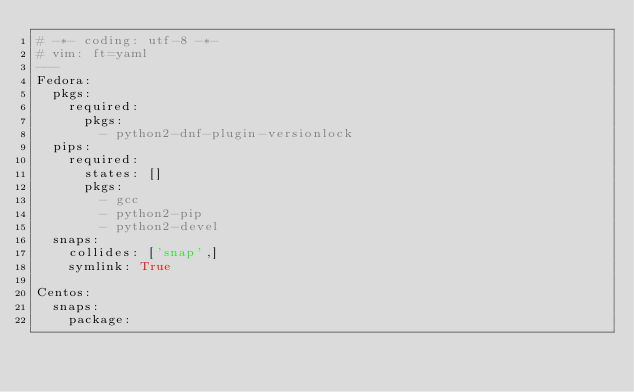Convert code to text. <code><loc_0><loc_0><loc_500><loc_500><_YAML_># -*- coding: utf-8 -*-
# vim: ft=yaml
---
Fedora:
  pkgs:
    required:
      pkgs:
        - python2-dnf-plugin-versionlock
  pips:
    required:
      states: []
      pkgs:
        - gcc
        - python2-pip
        - python2-devel
  snaps:
    collides: ['snap',]
    symlink: True

Centos:
  snaps:
    package:
</code> 